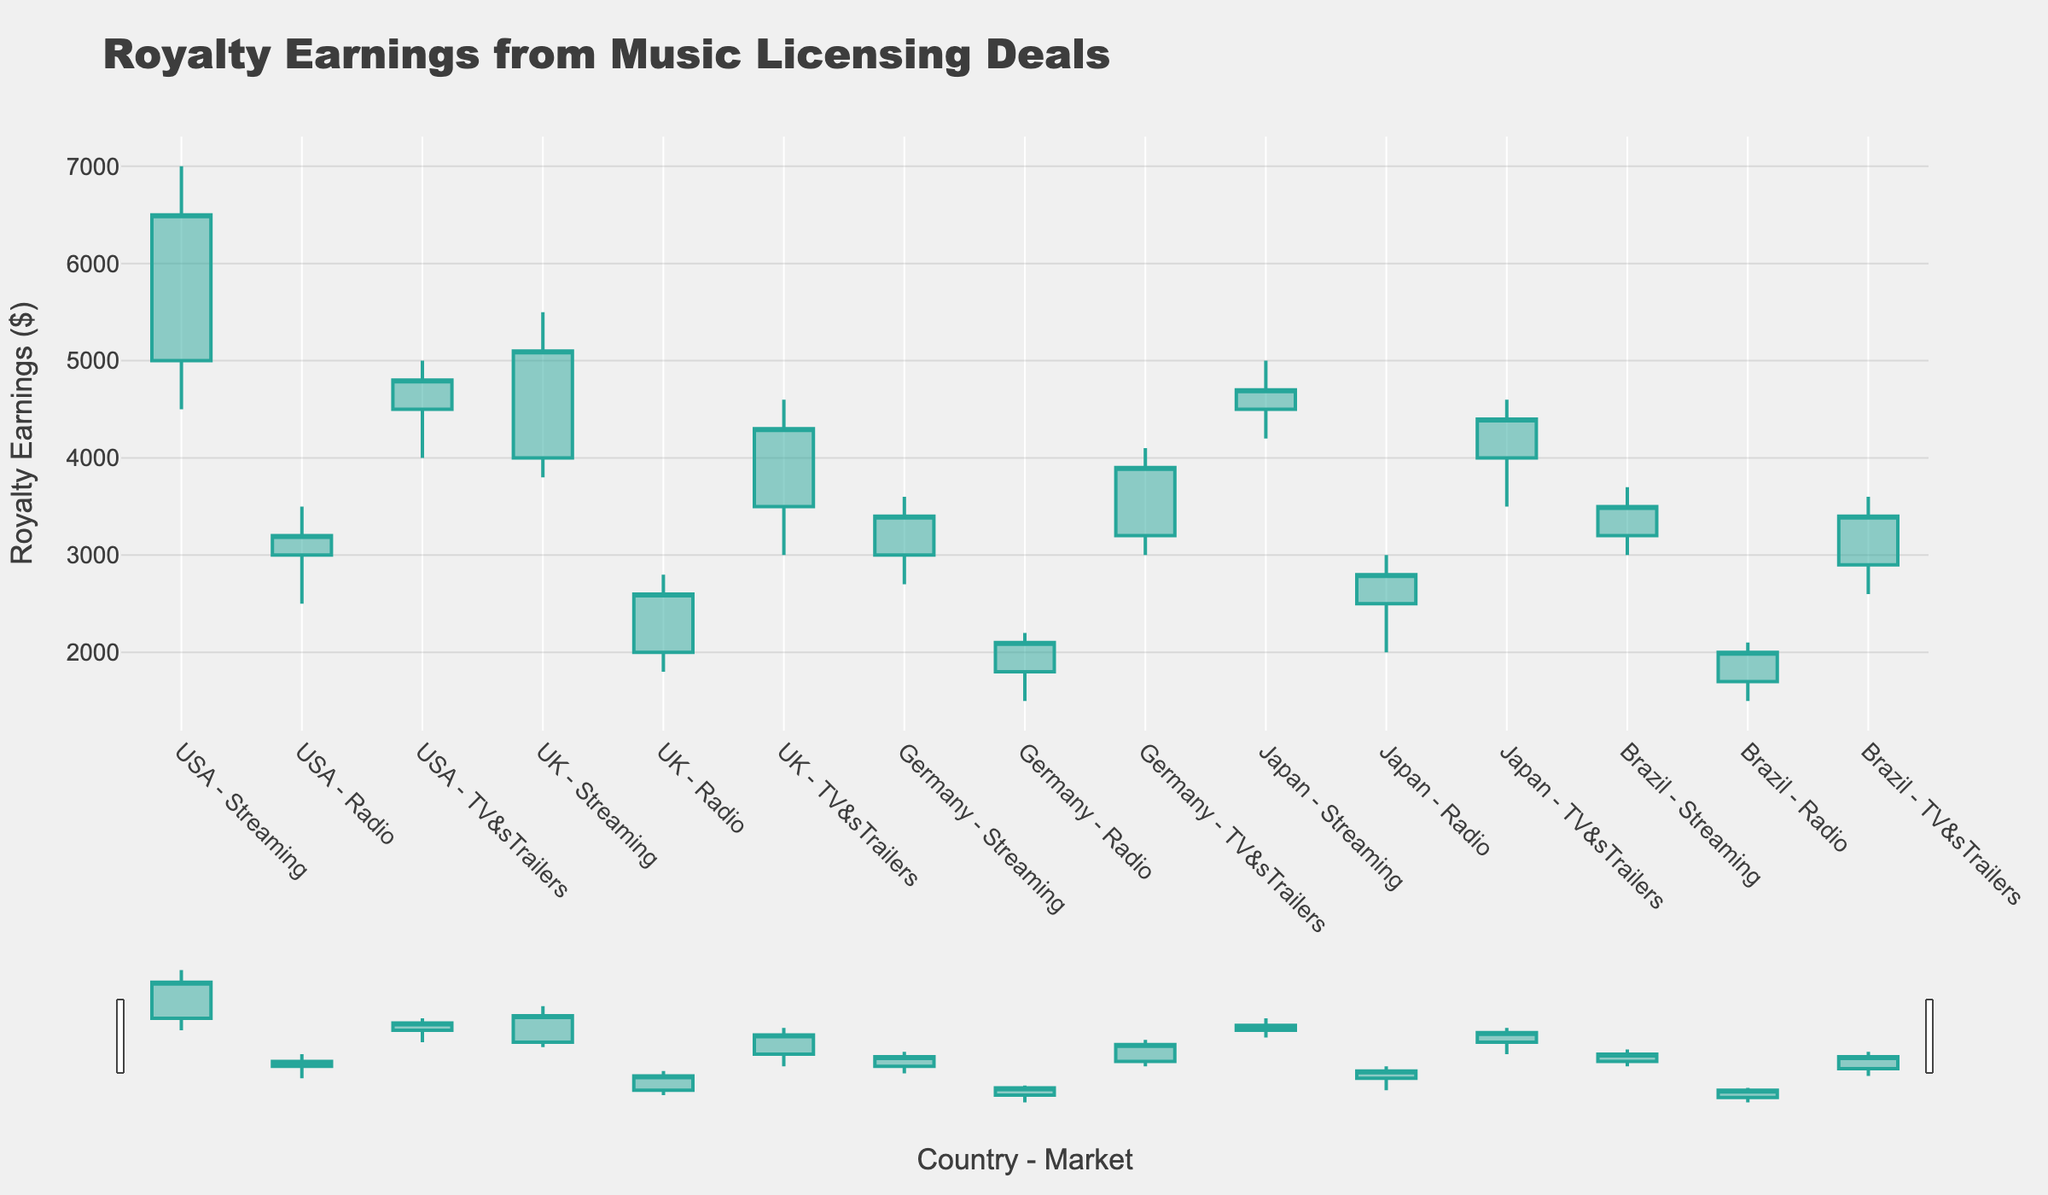What's the title of the chart? To find the title, look at the top section of the chart where large text written prominently indicates the subject of the chart.
Answer: Royalty Earnings from Music Licensing Deals How many different country-market combinations are displayed? Count the number of data points along the x-axis of the chart, where each point represents a different country-market combination.
Answer: 15 Which country-market combination has the highest royalty earning close value? Look for the candlestick that has the highest top close value along the y-axis. Each stick's position and values will help identify the highest close value.
Answer: USA - Streaming What is the average 'Open' value for the Streaming market across all countries? Sum the 'Open' values for the Streaming market (USA 5000, UK 4000, Germany 3000, Japan 4500, Brazil 3200) and divide by the number of countries (5).
Answer: 3940 Which country's radio market has the lowest 'Low' value? Compare the candlestick 'Low' values for the Radio markets across all countries, looking for the smallest 'Low' value.
Answer: Brazil How does the high value of UK Radio compare to the high value of Brazil TV & Trailers? Identify the top ends of the candlestick for UK Radio (2800) and Brazil TV & Trailers (3600) and compare these values.
Answer: Brazil TV & Trailers is higher What is the difference in close values between Japan Streaming and Germany TV & Trailers? Find the close values for Japan Streaming (4700) and Germany TV & Trailers (3900), then subtract the smaller from the larger.
Answer: 800 Which market within USA has the narrowest range between high and low values? Calculate the range (high - low) for each market in the USA (Streaming 2500, Radio 1000, TV & Trailers 1000) and identify the one with the smallest range.
Answer: USA Radio and TV & Trailers have equal narrow range What is the median close value among all the Radio markets? List all the close values for the Radio markets (USA 3200, UK 2600, Germany 2100, Japan 2800, Brazil 2000), order them (2000, 2100, 2600, 2800, 3200), and find the middle value.
Answer: 2600 Which market saw the biggest increase, i.e., has the highest positive difference between open and close values? Calculate the difference between open and close values for each market and find the one with the greatest increase (USA Streaming 1500, USA Radio 200, etc.).
Answer: USA Streaming 